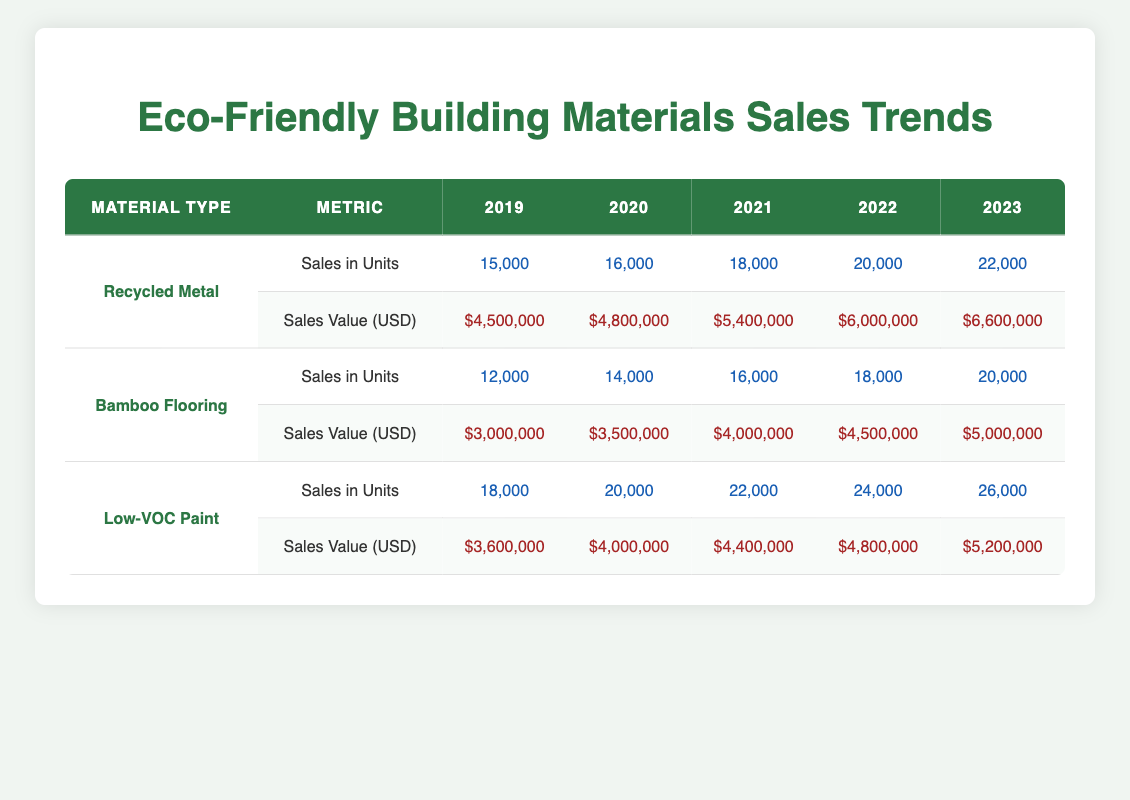What was the sales value of Low-VOC Paint in 2020? The sales value for Low-VOC Paint in 2020 can be found in the corresponding row and column of the table. It shows $4,000,000 for that year.
Answer: $4,000,000 Which material had the highest sales in units in 2023? To determine this, we look at the sales in units for each material type in 2023. Recycled Metal had 22,000 units, Bamboo Flooring had 20,000 units, and Low-VOC Paint had 26,000 units. Thus, Low-VOC Paint had the highest sales in units.
Answer: Low-VOC Paint What is the total sales value for Bamboo Flooring from 2019 to 2023? The sales values for Bamboo Flooring over the years are: 2019: $3,000,000, 2020: $3,500,000, 2021: $4,000,000, 2022: $4,500,000, and 2023: $5,000,000. Adding these values gives $3,000,000 + $3,500,000 + $4,000,000 + $4,500,000 + $5,000,000 = $20,000,000.
Answer: $20,000,000 Has the sales in units of Recycled Metal increased every year? By checking the sales in units for Recycled Metal: 2019 had 15,000 units, 2020 had 16,000 units, 2021 had 18,000 units, 2022 had 20,000 units, and 2023 had 22,000 units. All years show an increase. Hence, it is true that sales in units have increased every year.
Answer: Yes What was the average sales value of Low-VOC Paint from 2019 to 2023? The sales values for Low-VOC Paint are: $3,600,000 (2019), $4,000,000 (2020), $4,400,000 (2021), $4,800,000 (2022), and $5,200,000 (2023). To find the average, sum these amounts to get $3,600,000 + $4,000,000 + $4,400,000 + $4,800,000 + $5,200,000 = $22,000,000, and then divide by 5 (the number of values), resulting in $22,000,000 / 5 = $4,400,000.
Answer: $4,400,000 Which material type had the lowest sales in units in 2019? The table shows that in 2019, Recycled Metal had 15,000 units, Bamboo Flooring had 12,000 units, and Low-VOC Paint had 18,000 units. Of these, Bamboo Flooring had the fewest units sold.
Answer: Bamboo Flooring 